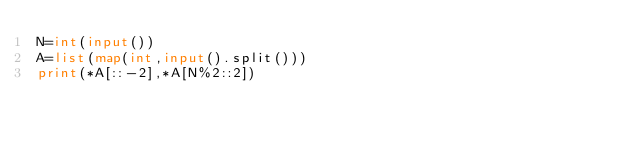Convert code to text. <code><loc_0><loc_0><loc_500><loc_500><_Python_>N=int(input())
A=list(map(int,input().split()))
print(*A[::-2],*A[N%2::2])</code> 